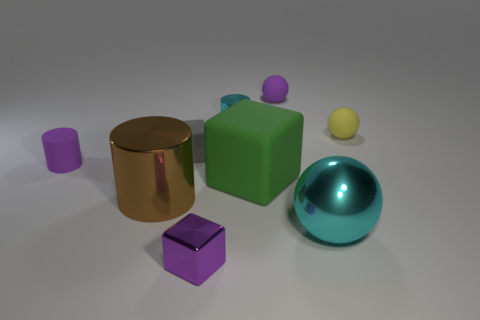Add 1 purple shiny things. How many objects exist? 10 Subtract all cubes. How many objects are left? 6 Subtract 0 gray cylinders. How many objects are left? 9 Subtract all tiny yellow matte cubes. Subtract all small matte balls. How many objects are left? 7 Add 6 cyan metal balls. How many cyan metal balls are left? 7 Add 8 large cyan shiny spheres. How many large cyan shiny spheres exist? 9 